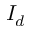Convert formula to latex. <formula><loc_0><loc_0><loc_500><loc_500>I _ { d }</formula> 